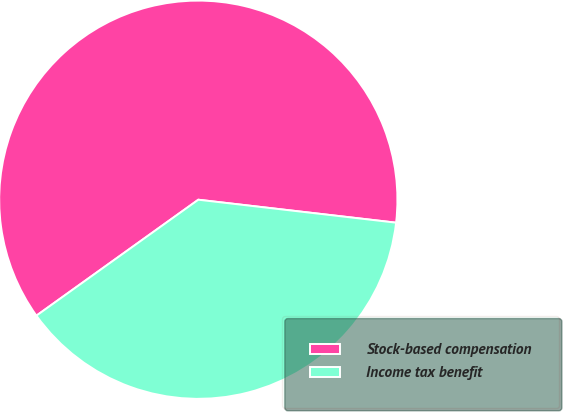Convert chart to OTSL. <chart><loc_0><loc_0><loc_500><loc_500><pie_chart><fcel>Stock-based compensation<fcel>Income tax benefit<nl><fcel>61.73%<fcel>38.27%<nl></chart> 